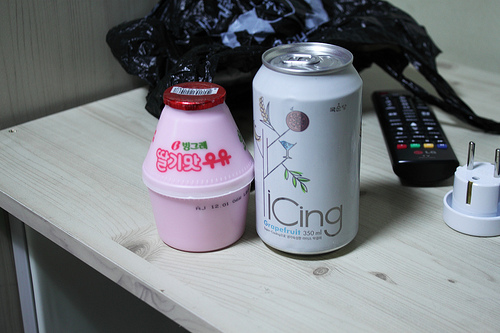<image>
Is there a can behind the remote? No. The can is not behind the remote. From this viewpoint, the can appears to be positioned elsewhere in the scene. Where is the milk in relation to the can? Is it in the can? No. The milk is not contained within the can. These objects have a different spatial relationship. Is the bag next to the remote? Yes. The bag is positioned adjacent to the remote, located nearby in the same general area. 